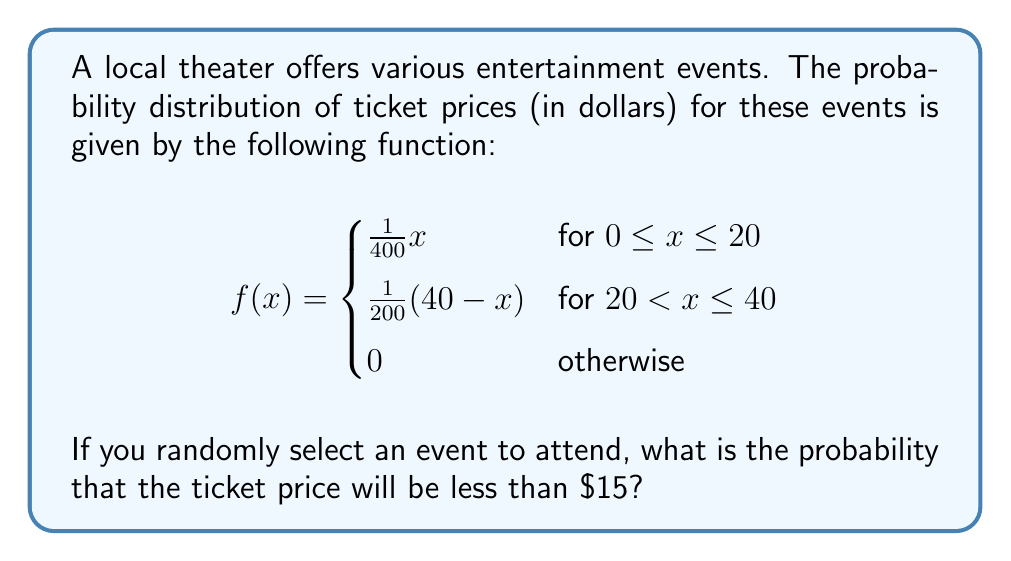Give your solution to this math problem. To find the probability that the ticket price will be less than $15, we need to integrate the probability density function from 0 to 15.

Since $15 is in the first interval of the piecewise function (0 ≤ x ≤ 20), we only need to use the first part of the function:

$$f(x) = \frac{1}{400}x \text{ for } 0 \leq x \leq 20$$

The probability is given by:

$$P(X < 15) = \int_0^{15} \frac{1}{400}x \, dx$$

Integrating:

$$\begin{align}
P(X < 15) &= \frac{1}{400} \int_0^{15} x \, dx \\
&= \frac{1}{400} \left[ \frac{x^2}{2} \right]_0^{15} \\
&= \frac{1}{400} \left( \frac{15^2}{2} - \frac{0^2}{2} \right) \\
&= \frac{1}{400} \cdot \frac{225}{2} \\
&= \frac{9}{32} \\
&\approx 0.28125
\end{align}$$

Therefore, the probability that a randomly selected event will have a ticket price less than $15 is $\frac{9}{32}$ or approximately 0.28125 or 28.125%.
Answer: $\frac{9}{32}$ 